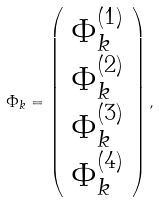Convert formula to latex. <formula><loc_0><loc_0><loc_500><loc_500>\Phi _ { k } = \left ( \begin{array} { c } \Phi _ { k } ^ { ( 1 ) } \\ \Phi _ { k } ^ { ( 2 ) } \\ \Phi _ { k } ^ { ( 3 ) } \\ \Phi _ { k } ^ { ( 4 ) } \end{array} \right ) ,</formula> 